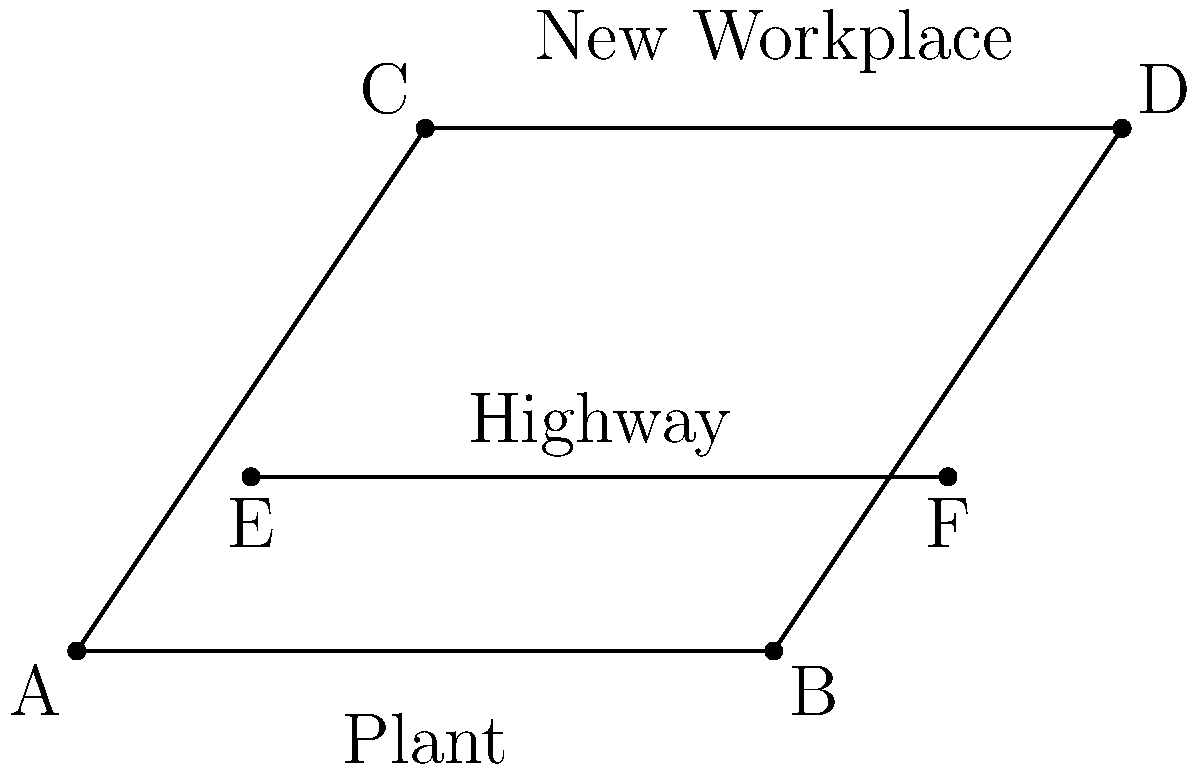After the plant closure, employees need to commute to a new workplace. Given the map showing the old plant location (AB), the new workplace location (CD), and a highway (EF), what is the most efficient route for employees to take from point A to point D? To find the most efficient route from point A to point D, we need to consider the following steps:

1. Direct route: The direct route from A to D would be a straight line, but this is not always the most efficient due to potential obstacles or lack of roads.

2. Using existing roads: The map shows a highway (EF) which can be utilized for faster travel.

3. Optimal path:
   a. Start at point A (old plant location)
   b. Travel north to reach point E on the highway
   c. Take the highway from E to F
   d. From point F, travel north to reach point D (new workplace)

4. This route minimizes the distance traveled on slower local roads and maximizes the use of the faster highway.

5. The path A→E→F→D forms two right triangles (AEF and FCD), which is more efficient than following the perimeter of the quadrilateral ABCD.

6. This route also avoids any potential traffic or obstacles in the city center between the old plant and new workplace.
Answer: A→E→F→D 